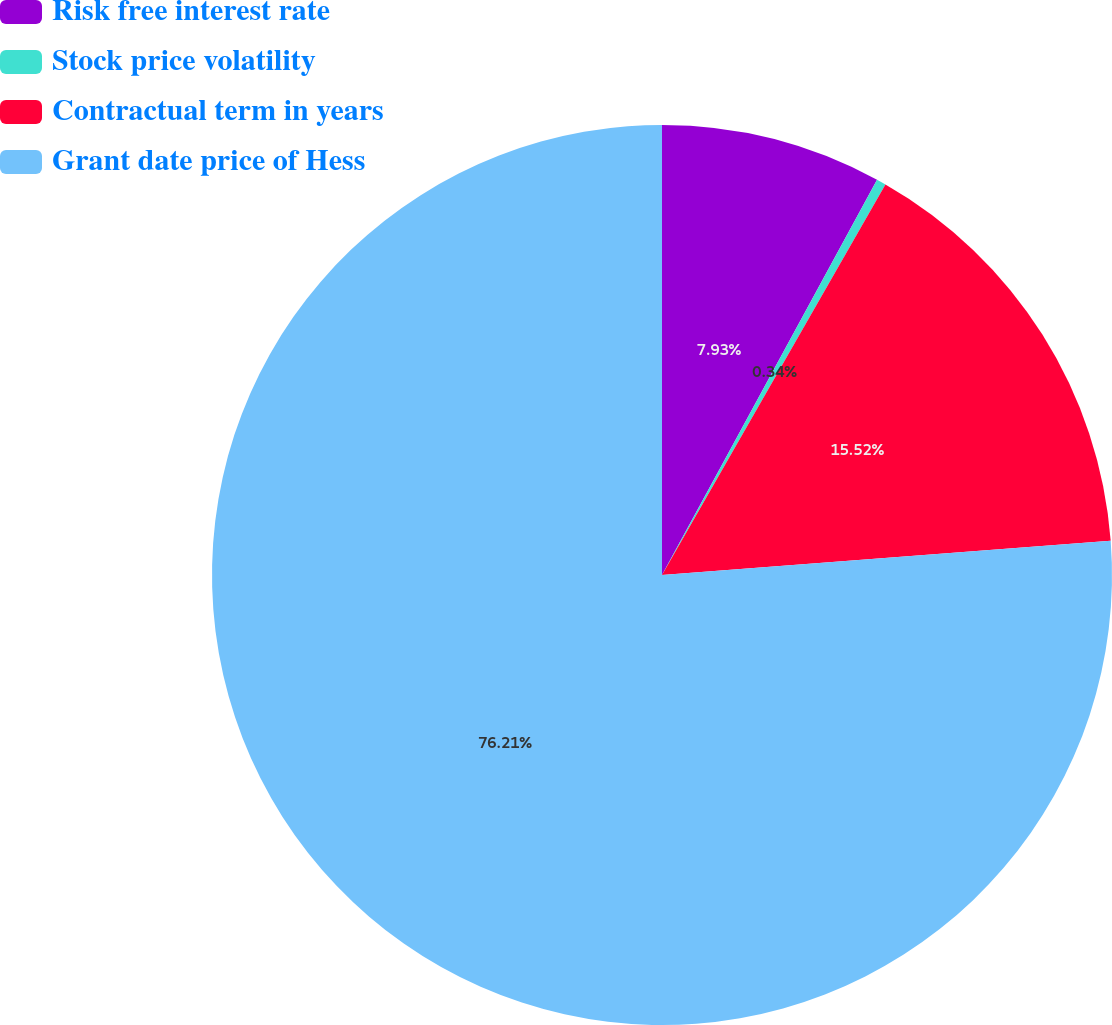<chart> <loc_0><loc_0><loc_500><loc_500><pie_chart><fcel>Risk free interest rate<fcel>Stock price volatility<fcel>Contractual term in years<fcel>Grant date price of Hess<nl><fcel>7.93%<fcel>0.34%<fcel>15.52%<fcel>76.21%<nl></chart> 